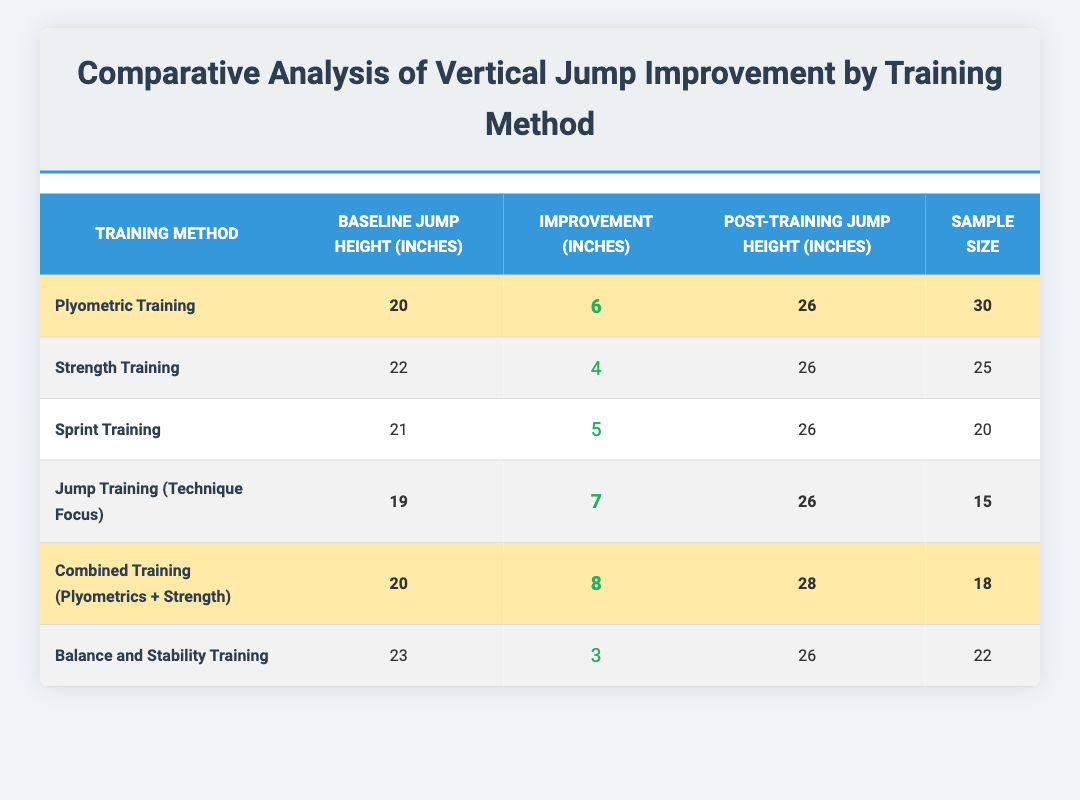What is the improvement in jump height for Plyometric Training? The improvement for Plyometric Training is listed as 6 inches in the table.
Answer: 6 inches Which training method resulted in the highest vertical jump improvement? The table shows that Combined Training (Plyometrics + Strength) had the highest improvement of 8 inches.
Answer: Combined Training (Plyometrics + Strength) What was the post-training jump height for Strength Training? According to the table, the post-training jump height for Strength Training is 26 inches.
Answer: 26 inches How many participants were involved in Jump Training (Technique Focus)? The sample size for Jump Training (Technique Focus) is 15, as per the table.
Answer: 15 What is the average jump improvement across all listed training methods? The improvements listed are 6, 4, 5, 7, 8, and 3 inches, totaling 33 inches. Dividing this by the 6 methods gives an average improvement of 5.5 inches.
Answer: 5.5 inches Did Balance and Stability Training produce more improvement than Strength Training? Balance and Stability Training had an improvement of 3 inches, while Strength Training improved by 4 inches, so it did not produce more improvement.
Answer: No What is the difference in post-training jump height between Combined Training and Plyometric Training? The post-training height for Combined Training is 28 inches, and for Plyometric Training, it is 26 inches. The difference is 28 - 26 = 2 inches.
Answer: 2 inches What training method with the highest improvement had the lowest baseline jump height? Jump Training (Technique Focus) achieved an improvement of 7 inches and had the lowest baseline jump height of 19 inches among the highlighted methods.
Answer: Jump Training (Technique Focus) How many participants were involved in the combined methods? The training methods that are highlighted (Plyometric Training, Jump Training, and Combined Training) have sample sizes of 30, 15, and 18 respectively, which adds up to 63 participants.
Answer: 63 Is the total improvement from all highlighted methods greater than 25 inches? The improvements from highlighted methods are 6 (Plyometric) + 7 (Jump Training) + 8 (Combined) = 21 inches, which is less than 25 inches.
Answer: No 